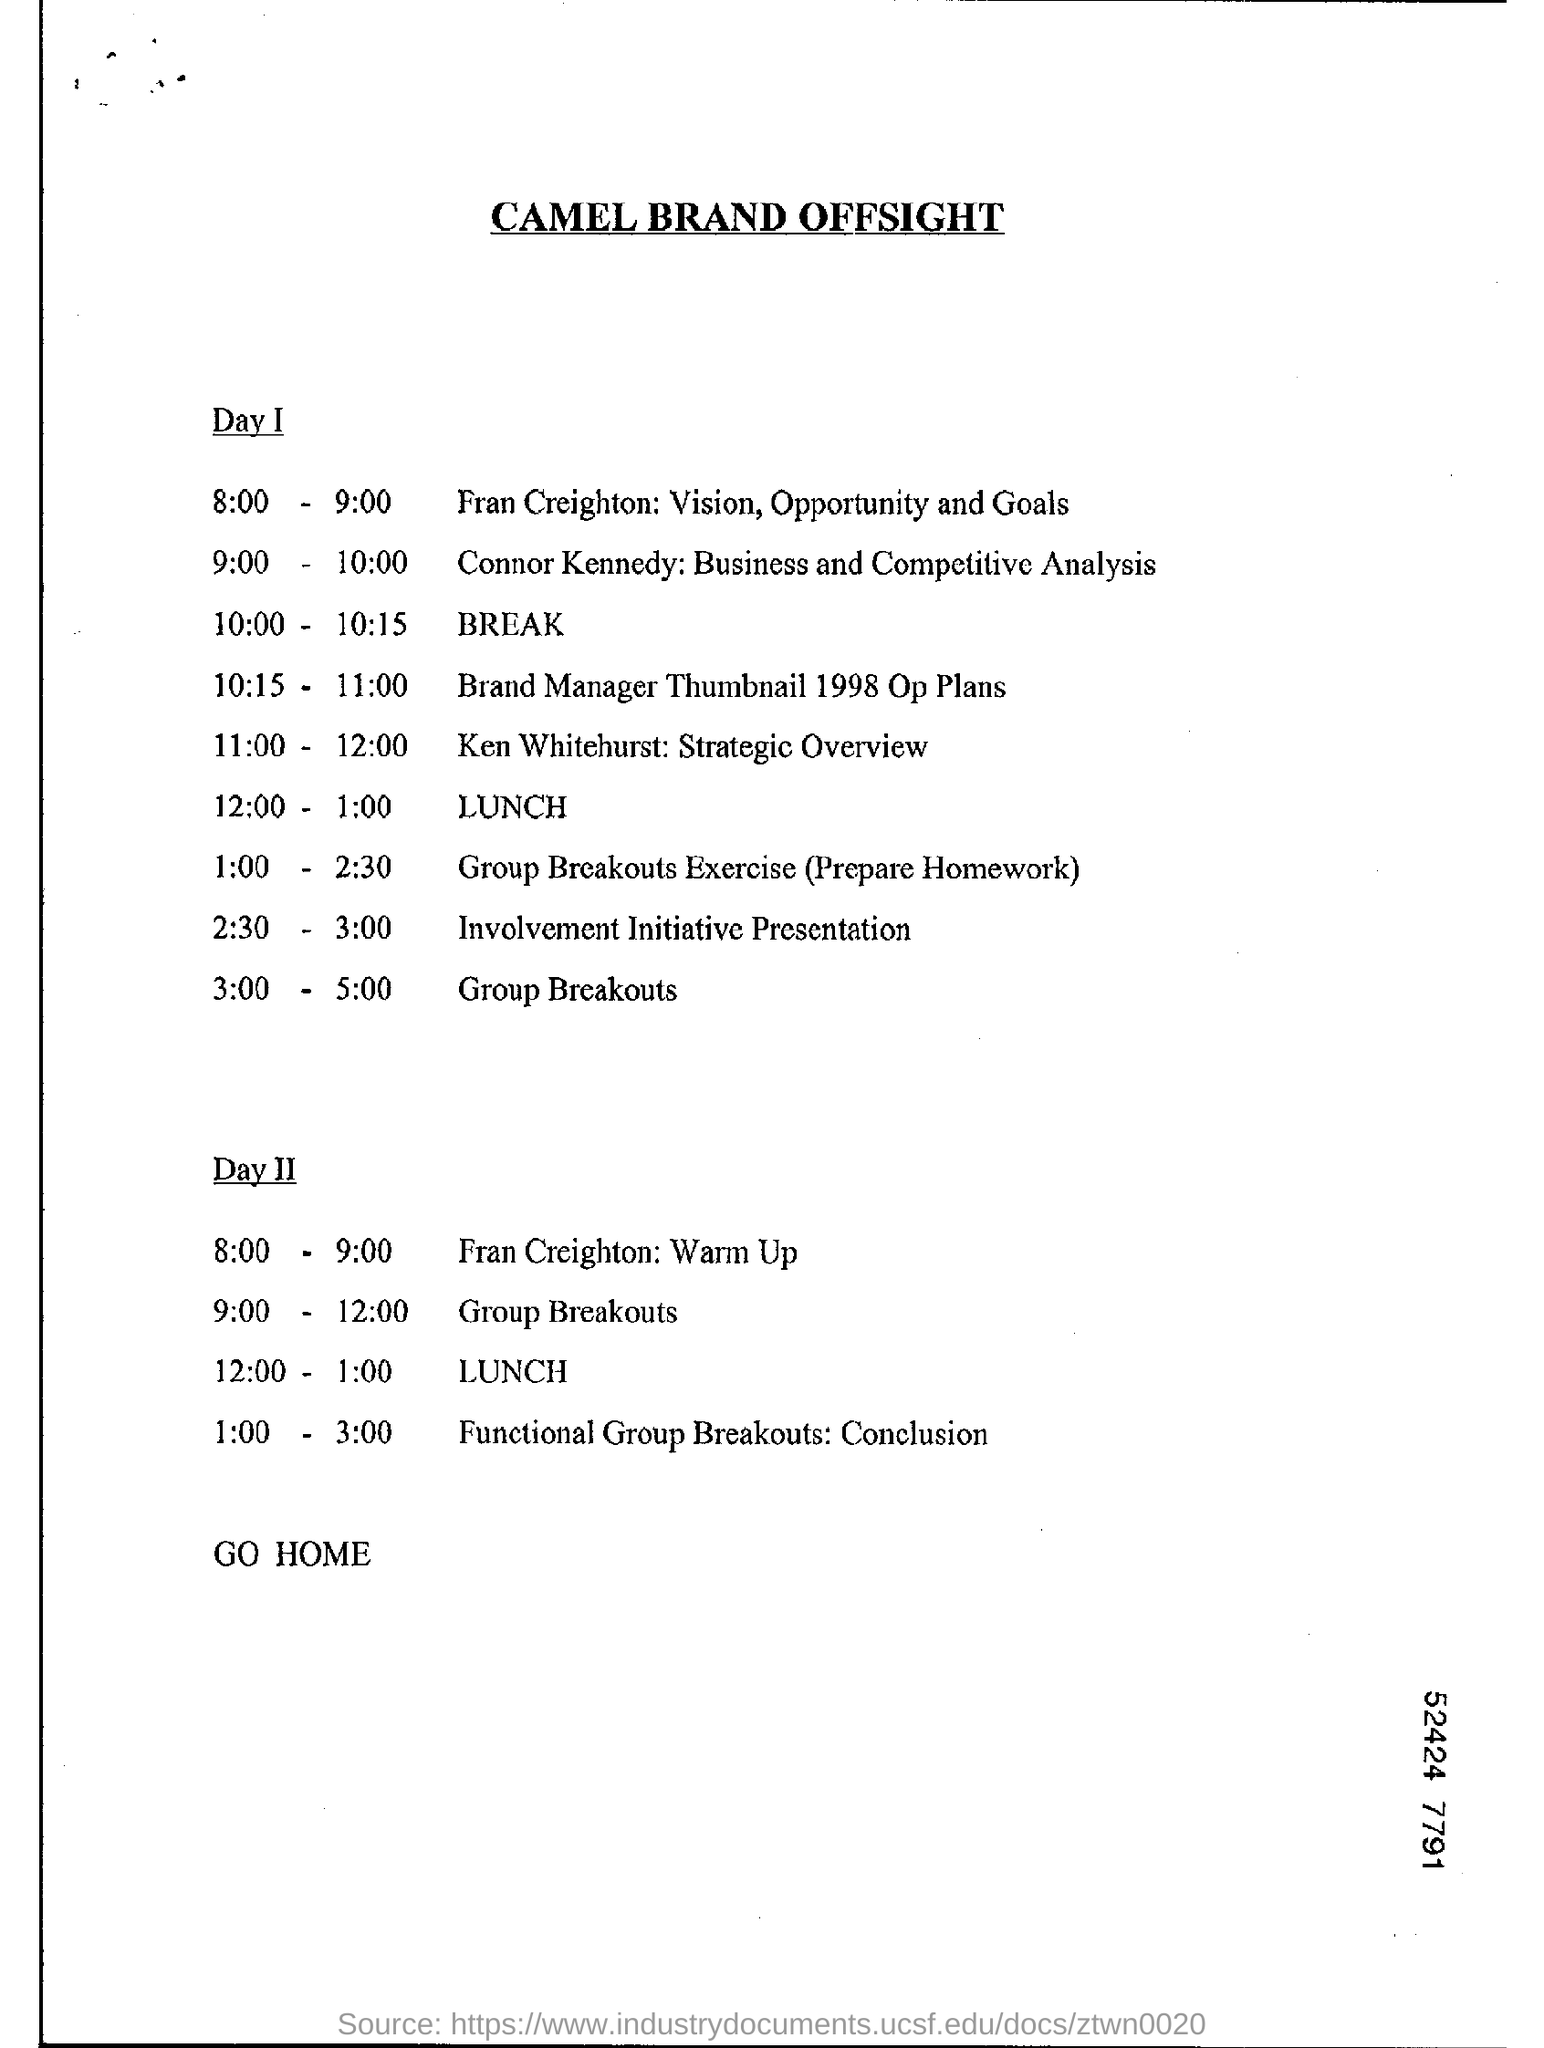Indicate a few pertinent items in this graphic. The Ken Whitehurst: Strategic Overview is scheduled to take place on Day I. The title of the document is 'CAMEL BRAND OFFSIGHT.'  On Day II from 9:00 AM to 12:00 PM, the program scheduled is Group Breakouts. 